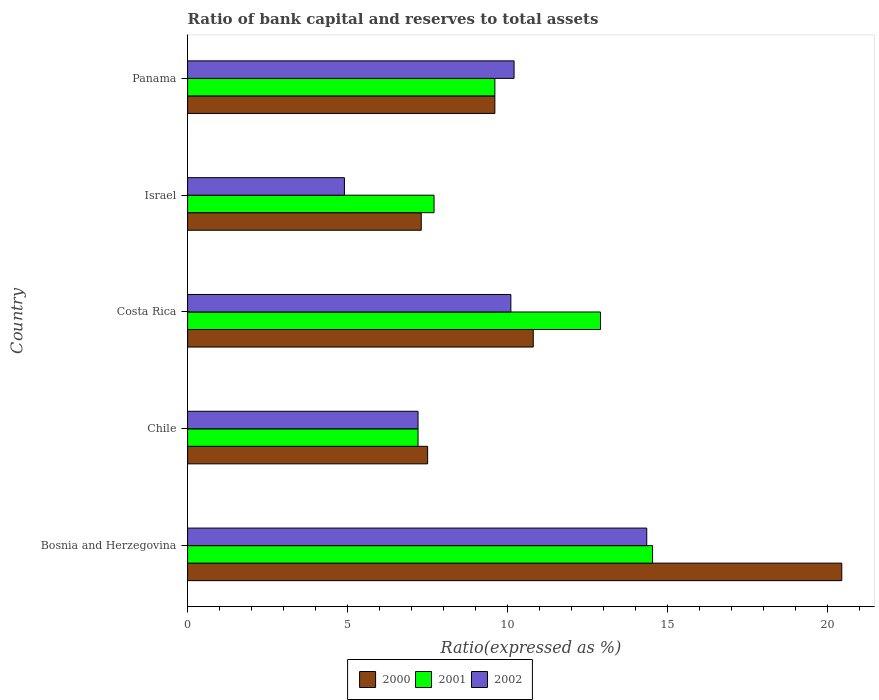How many different coloured bars are there?
Give a very brief answer. 3. How many groups of bars are there?
Give a very brief answer. 5. How many bars are there on the 5th tick from the top?
Offer a terse response. 3. How many bars are there on the 2nd tick from the bottom?
Ensure brevity in your answer.  3. What is the label of the 5th group of bars from the top?
Make the answer very short. Bosnia and Herzegovina. In how many cases, is the number of bars for a given country not equal to the number of legend labels?
Provide a short and direct response. 0. Across all countries, what is the maximum ratio of bank capital and reserves to total assets in 2000?
Make the answer very short. 20.44. In which country was the ratio of bank capital and reserves to total assets in 2000 maximum?
Your answer should be compact. Bosnia and Herzegovina. What is the total ratio of bank capital and reserves to total assets in 2000 in the graph?
Give a very brief answer. 55.64. What is the difference between the ratio of bank capital and reserves to total assets in 2002 in Chile and that in Israel?
Give a very brief answer. 2.3. What is the difference between the ratio of bank capital and reserves to total assets in 2000 in Chile and the ratio of bank capital and reserves to total assets in 2002 in Costa Rica?
Ensure brevity in your answer.  -2.6. What is the average ratio of bank capital and reserves to total assets in 2001 per country?
Offer a terse response. 10.39. What is the difference between the ratio of bank capital and reserves to total assets in 2001 and ratio of bank capital and reserves to total assets in 2000 in Bosnia and Herzegovina?
Ensure brevity in your answer.  -5.91. What is the ratio of the ratio of bank capital and reserves to total assets in 2000 in Bosnia and Herzegovina to that in Chile?
Provide a succinct answer. 2.73. Is the ratio of bank capital and reserves to total assets in 2001 in Bosnia and Herzegovina less than that in Costa Rica?
Keep it short and to the point. No. Is the difference between the ratio of bank capital and reserves to total assets in 2001 in Chile and Costa Rica greater than the difference between the ratio of bank capital and reserves to total assets in 2000 in Chile and Costa Rica?
Give a very brief answer. No. What is the difference between the highest and the second highest ratio of bank capital and reserves to total assets in 2000?
Your answer should be compact. 9.64. What is the difference between the highest and the lowest ratio of bank capital and reserves to total assets in 2000?
Provide a short and direct response. 13.14. In how many countries, is the ratio of bank capital and reserves to total assets in 2001 greater than the average ratio of bank capital and reserves to total assets in 2001 taken over all countries?
Offer a terse response. 2. What does the 3rd bar from the top in Israel represents?
Provide a succinct answer. 2000. Are all the bars in the graph horizontal?
Provide a short and direct response. Yes. What is the difference between two consecutive major ticks on the X-axis?
Offer a terse response. 5. Are the values on the major ticks of X-axis written in scientific E-notation?
Offer a very short reply. No. Does the graph contain any zero values?
Make the answer very short. No. Does the graph contain grids?
Keep it short and to the point. No. Where does the legend appear in the graph?
Your answer should be compact. Bottom center. How many legend labels are there?
Keep it short and to the point. 3. How are the legend labels stacked?
Keep it short and to the point. Horizontal. What is the title of the graph?
Offer a very short reply. Ratio of bank capital and reserves to total assets. Does "1968" appear as one of the legend labels in the graph?
Provide a succinct answer. No. What is the label or title of the X-axis?
Keep it short and to the point. Ratio(expressed as %). What is the Ratio(expressed as %) in 2000 in Bosnia and Herzegovina?
Keep it short and to the point. 20.44. What is the Ratio(expressed as %) of 2001 in Bosnia and Herzegovina?
Ensure brevity in your answer.  14.53. What is the Ratio(expressed as %) of 2002 in Bosnia and Herzegovina?
Ensure brevity in your answer.  14.35. What is the Ratio(expressed as %) of 2001 in Costa Rica?
Keep it short and to the point. 12.9. What is the Ratio(expressed as %) in 2002 in Costa Rica?
Ensure brevity in your answer.  10.1. What is the Ratio(expressed as %) in 2002 in Israel?
Make the answer very short. 4.9. What is the Ratio(expressed as %) in 2002 in Panama?
Ensure brevity in your answer.  10.2. Across all countries, what is the maximum Ratio(expressed as %) of 2000?
Keep it short and to the point. 20.44. Across all countries, what is the maximum Ratio(expressed as %) in 2001?
Keep it short and to the point. 14.53. Across all countries, what is the maximum Ratio(expressed as %) of 2002?
Offer a very short reply. 14.35. Across all countries, what is the minimum Ratio(expressed as %) of 2000?
Keep it short and to the point. 7.3. Across all countries, what is the minimum Ratio(expressed as %) in 2001?
Provide a succinct answer. 7.2. Across all countries, what is the minimum Ratio(expressed as %) of 2002?
Offer a very short reply. 4.9. What is the total Ratio(expressed as %) in 2000 in the graph?
Provide a short and direct response. 55.64. What is the total Ratio(expressed as %) in 2001 in the graph?
Your answer should be compact. 51.93. What is the total Ratio(expressed as %) in 2002 in the graph?
Your response must be concise. 46.75. What is the difference between the Ratio(expressed as %) of 2000 in Bosnia and Herzegovina and that in Chile?
Provide a succinct answer. 12.94. What is the difference between the Ratio(expressed as %) of 2001 in Bosnia and Herzegovina and that in Chile?
Provide a short and direct response. 7.33. What is the difference between the Ratio(expressed as %) in 2002 in Bosnia and Herzegovina and that in Chile?
Make the answer very short. 7.15. What is the difference between the Ratio(expressed as %) of 2000 in Bosnia and Herzegovina and that in Costa Rica?
Keep it short and to the point. 9.64. What is the difference between the Ratio(expressed as %) of 2001 in Bosnia and Herzegovina and that in Costa Rica?
Provide a succinct answer. 1.63. What is the difference between the Ratio(expressed as %) in 2002 in Bosnia and Herzegovina and that in Costa Rica?
Ensure brevity in your answer.  4.25. What is the difference between the Ratio(expressed as %) of 2000 in Bosnia and Herzegovina and that in Israel?
Provide a short and direct response. 13.14. What is the difference between the Ratio(expressed as %) in 2001 in Bosnia and Herzegovina and that in Israel?
Provide a short and direct response. 6.83. What is the difference between the Ratio(expressed as %) of 2002 in Bosnia and Herzegovina and that in Israel?
Offer a very short reply. 9.45. What is the difference between the Ratio(expressed as %) of 2000 in Bosnia and Herzegovina and that in Panama?
Provide a succinct answer. 10.84. What is the difference between the Ratio(expressed as %) in 2001 in Bosnia and Herzegovina and that in Panama?
Make the answer very short. 4.93. What is the difference between the Ratio(expressed as %) in 2002 in Bosnia and Herzegovina and that in Panama?
Make the answer very short. 4.15. What is the difference between the Ratio(expressed as %) of 2000 in Chile and that in Costa Rica?
Offer a very short reply. -3.3. What is the difference between the Ratio(expressed as %) in 2000 in Chile and that in Israel?
Offer a terse response. 0.2. What is the difference between the Ratio(expressed as %) of 2002 in Chile and that in Israel?
Ensure brevity in your answer.  2.3. What is the difference between the Ratio(expressed as %) of 2000 in Costa Rica and that in Israel?
Your answer should be very brief. 3.5. What is the difference between the Ratio(expressed as %) of 2000 in Costa Rica and that in Panama?
Provide a short and direct response. 1.2. What is the difference between the Ratio(expressed as %) of 2001 in Costa Rica and that in Panama?
Keep it short and to the point. 3.3. What is the difference between the Ratio(expressed as %) of 2002 in Costa Rica and that in Panama?
Provide a short and direct response. -0.1. What is the difference between the Ratio(expressed as %) in 2001 in Israel and that in Panama?
Ensure brevity in your answer.  -1.9. What is the difference between the Ratio(expressed as %) in 2000 in Bosnia and Herzegovina and the Ratio(expressed as %) in 2001 in Chile?
Provide a succinct answer. 13.24. What is the difference between the Ratio(expressed as %) in 2000 in Bosnia and Herzegovina and the Ratio(expressed as %) in 2002 in Chile?
Your answer should be compact. 13.24. What is the difference between the Ratio(expressed as %) in 2001 in Bosnia and Herzegovina and the Ratio(expressed as %) in 2002 in Chile?
Give a very brief answer. 7.33. What is the difference between the Ratio(expressed as %) in 2000 in Bosnia and Herzegovina and the Ratio(expressed as %) in 2001 in Costa Rica?
Provide a succinct answer. 7.54. What is the difference between the Ratio(expressed as %) of 2000 in Bosnia and Herzegovina and the Ratio(expressed as %) of 2002 in Costa Rica?
Offer a very short reply. 10.34. What is the difference between the Ratio(expressed as %) in 2001 in Bosnia and Herzegovina and the Ratio(expressed as %) in 2002 in Costa Rica?
Offer a terse response. 4.43. What is the difference between the Ratio(expressed as %) of 2000 in Bosnia and Herzegovina and the Ratio(expressed as %) of 2001 in Israel?
Your answer should be compact. 12.74. What is the difference between the Ratio(expressed as %) of 2000 in Bosnia and Herzegovina and the Ratio(expressed as %) of 2002 in Israel?
Offer a very short reply. 15.54. What is the difference between the Ratio(expressed as %) of 2001 in Bosnia and Herzegovina and the Ratio(expressed as %) of 2002 in Israel?
Make the answer very short. 9.63. What is the difference between the Ratio(expressed as %) in 2000 in Bosnia and Herzegovina and the Ratio(expressed as %) in 2001 in Panama?
Give a very brief answer. 10.84. What is the difference between the Ratio(expressed as %) of 2000 in Bosnia and Herzegovina and the Ratio(expressed as %) of 2002 in Panama?
Make the answer very short. 10.24. What is the difference between the Ratio(expressed as %) of 2001 in Bosnia and Herzegovina and the Ratio(expressed as %) of 2002 in Panama?
Give a very brief answer. 4.33. What is the difference between the Ratio(expressed as %) in 2000 in Chile and the Ratio(expressed as %) in 2002 in Costa Rica?
Keep it short and to the point. -2.6. What is the difference between the Ratio(expressed as %) in 2001 in Chile and the Ratio(expressed as %) in 2002 in Costa Rica?
Give a very brief answer. -2.9. What is the difference between the Ratio(expressed as %) in 2000 in Chile and the Ratio(expressed as %) in 2001 in Israel?
Provide a short and direct response. -0.2. What is the difference between the Ratio(expressed as %) in 2000 in Chile and the Ratio(expressed as %) in 2002 in Israel?
Offer a very short reply. 2.6. What is the difference between the Ratio(expressed as %) of 2001 in Chile and the Ratio(expressed as %) of 2002 in Israel?
Ensure brevity in your answer.  2.3. What is the difference between the Ratio(expressed as %) of 2001 in Chile and the Ratio(expressed as %) of 2002 in Panama?
Offer a very short reply. -3. What is the difference between the Ratio(expressed as %) of 2000 in Costa Rica and the Ratio(expressed as %) of 2001 in Israel?
Offer a terse response. 3.1. What is the difference between the Ratio(expressed as %) in 2001 in Costa Rica and the Ratio(expressed as %) in 2002 in Israel?
Offer a terse response. 8. What is the difference between the Ratio(expressed as %) in 2000 in Israel and the Ratio(expressed as %) in 2002 in Panama?
Your answer should be compact. -2.9. What is the difference between the Ratio(expressed as %) of 2001 in Israel and the Ratio(expressed as %) of 2002 in Panama?
Your answer should be very brief. -2.5. What is the average Ratio(expressed as %) of 2000 per country?
Give a very brief answer. 11.13. What is the average Ratio(expressed as %) in 2001 per country?
Make the answer very short. 10.39. What is the average Ratio(expressed as %) of 2002 per country?
Ensure brevity in your answer.  9.35. What is the difference between the Ratio(expressed as %) of 2000 and Ratio(expressed as %) of 2001 in Bosnia and Herzegovina?
Provide a short and direct response. 5.91. What is the difference between the Ratio(expressed as %) in 2000 and Ratio(expressed as %) in 2002 in Bosnia and Herzegovina?
Ensure brevity in your answer.  6.09. What is the difference between the Ratio(expressed as %) of 2001 and Ratio(expressed as %) of 2002 in Bosnia and Herzegovina?
Offer a terse response. 0.18. What is the difference between the Ratio(expressed as %) in 2000 and Ratio(expressed as %) in 2002 in Chile?
Make the answer very short. 0.3. What is the difference between the Ratio(expressed as %) of 2001 and Ratio(expressed as %) of 2002 in Chile?
Make the answer very short. 0. What is the difference between the Ratio(expressed as %) in 2000 and Ratio(expressed as %) in 2001 in Costa Rica?
Keep it short and to the point. -2.1. What is the difference between the Ratio(expressed as %) in 2000 and Ratio(expressed as %) in 2001 in Israel?
Offer a very short reply. -0.4. What is the difference between the Ratio(expressed as %) of 2001 and Ratio(expressed as %) of 2002 in Israel?
Ensure brevity in your answer.  2.8. What is the difference between the Ratio(expressed as %) in 2000 and Ratio(expressed as %) in 2001 in Panama?
Ensure brevity in your answer.  0. What is the difference between the Ratio(expressed as %) of 2001 and Ratio(expressed as %) of 2002 in Panama?
Your answer should be very brief. -0.6. What is the ratio of the Ratio(expressed as %) in 2000 in Bosnia and Herzegovina to that in Chile?
Offer a terse response. 2.73. What is the ratio of the Ratio(expressed as %) in 2001 in Bosnia and Herzegovina to that in Chile?
Provide a short and direct response. 2.02. What is the ratio of the Ratio(expressed as %) of 2002 in Bosnia and Herzegovina to that in Chile?
Keep it short and to the point. 1.99. What is the ratio of the Ratio(expressed as %) of 2000 in Bosnia and Herzegovina to that in Costa Rica?
Offer a terse response. 1.89. What is the ratio of the Ratio(expressed as %) in 2001 in Bosnia and Herzegovina to that in Costa Rica?
Your answer should be compact. 1.13. What is the ratio of the Ratio(expressed as %) in 2002 in Bosnia and Herzegovina to that in Costa Rica?
Provide a succinct answer. 1.42. What is the ratio of the Ratio(expressed as %) in 2000 in Bosnia and Herzegovina to that in Israel?
Provide a succinct answer. 2.8. What is the ratio of the Ratio(expressed as %) of 2001 in Bosnia and Herzegovina to that in Israel?
Offer a very short reply. 1.89. What is the ratio of the Ratio(expressed as %) in 2002 in Bosnia and Herzegovina to that in Israel?
Offer a terse response. 2.93. What is the ratio of the Ratio(expressed as %) in 2000 in Bosnia and Herzegovina to that in Panama?
Your answer should be very brief. 2.13. What is the ratio of the Ratio(expressed as %) of 2001 in Bosnia and Herzegovina to that in Panama?
Give a very brief answer. 1.51. What is the ratio of the Ratio(expressed as %) of 2002 in Bosnia and Herzegovina to that in Panama?
Your answer should be compact. 1.41. What is the ratio of the Ratio(expressed as %) in 2000 in Chile to that in Costa Rica?
Offer a very short reply. 0.69. What is the ratio of the Ratio(expressed as %) in 2001 in Chile to that in Costa Rica?
Your response must be concise. 0.56. What is the ratio of the Ratio(expressed as %) in 2002 in Chile to that in Costa Rica?
Your response must be concise. 0.71. What is the ratio of the Ratio(expressed as %) in 2000 in Chile to that in Israel?
Provide a succinct answer. 1.03. What is the ratio of the Ratio(expressed as %) of 2001 in Chile to that in Israel?
Your answer should be very brief. 0.94. What is the ratio of the Ratio(expressed as %) in 2002 in Chile to that in Israel?
Your response must be concise. 1.47. What is the ratio of the Ratio(expressed as %) of 2000 in Chile to that in Panama?
Offer a terse response. 0.78. What is the ratio of the Ratio(expressed as %) in 2002 in Chile to that in Panama?
Offer a very short reply. 0.71. What is the ratio of the Ratio(expressed as %) of 2000 in Costa Rica to that in Israel?
Your answer should be very brief. 1.48. What is the ratio of the Ratio(expressed as %) of 2001 in Costa Rica to that in Israel?
Offer a terse response. 1.68. What is the ratio of the Ratio(expressed as %) in 2002 in Costa Rica to that in Israel?
Give a very brief answer. 2.06. What is the ratio of the Ratio(expressed as %) of 2001 in Costa Rica to that in Panama?
Offer a terse response. 1.34. What is the ratio of the Ratio(expressed as %) in 2002 in Costa Rica to that in Panama?
Your answer should be very brief. 0.99. What is the ratio of the Ratio(expressed as %) in 2000 in Israel to that in Panama?
Your answer should be very brief. 0.76. What is the ratio of the Ratio(expressed as %) in 2001 in Israel to that in Panama?
Give a very brief answer. 0.8. What is the ratio of the Ratio(expressed as %) of 2002 in Israel to that in Panama?
Your response must be concise. 0.48. What is the difference between the highest and the second highest Ratio(expressed as %) in 2000?
Offer a terse response. 9.64. What is the difference between the highest and the second highest Ratio(expressed as %) of 2001?
Keep it short and to the point. 1.63. What is the difference between the highest and the second highest Ratio(expressed as %) in 2002?
Keep it short and to the point. 4.15. What is the difference between the highest and the lowest Ratio(expressed as %) of 2000?
Your answer should be compact. 13.14. What is the difference between the highest and the lowest Ratio(expressed as %) of 2001?
Provide a succinct answer. 7.33. What is the difference between the highest and the lowest Ratio(expressed as %) of 2002?
Give a very brief answer. 9.45. 